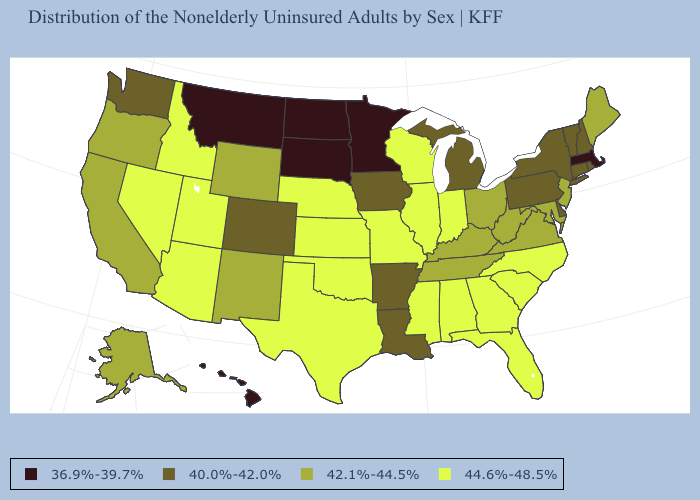Name the states that have a value in the range 40.0%-42.0%?
Short answer required. Arkansas, Colorado, Connecticut, Delaware, Iowa, Louisiana, Michigan, New Hampshire, New York, Pennsylvania, Rhode Island, Vermont, Washington. What is the lowest value in the Northeast?
Give a very brief answer. 36.9%-39.7%. What is the value of Utah?
Keep it brief. 44.6%-48.5%. How many symbols are there in the legend?
Concise answer only. 4. Does New Hampshire have the lowest value in the Northeast?
Write a very short answer. No. What is the value of Wisconsin?
Concise answer only. 44.6%-48.5%. Name the states that have a value in the range 44.6%-48.5%?
Be succinct. Alabama, Arizona, Florida, Georgia, Idaho, Illinois, Indiana, Kansas, Mississippi, Missouri, Nebraska, Nevada, North Carolina, Oklahoma, South Carolina, Texas, Utah, Wisconsin. Name the states that have a value in the range 40.0%-42.0%?
Give a very brief answer. Arkansas, Colorado, Connecticut, Delaware, Iowa, Louisiana, Michigan, New Hampshire, New York, Pennsylvania, Rhode Island, Vermont, Washington. What is the value of Minnesota?
Write a very short answer. 36.9%-39.7%. What is the lowest value in the Northeast?
Be succinct. 36.9%-39.7%. What is the lowest value in states that border Mississippi?
Write a very short answer. 40.0%-42.0%. What is the value of Utah?
Be succinct. 44.6%-48.5%. Does North Carolina have the lowest value in the USA?
Give a very brief answer. No. What is the highest value in states that border Pennsylvania?
Answer briefly. 42.1%-44.5%. Does the first symbol in the legend represent the smallest category?
Keep it brief. Yes. 